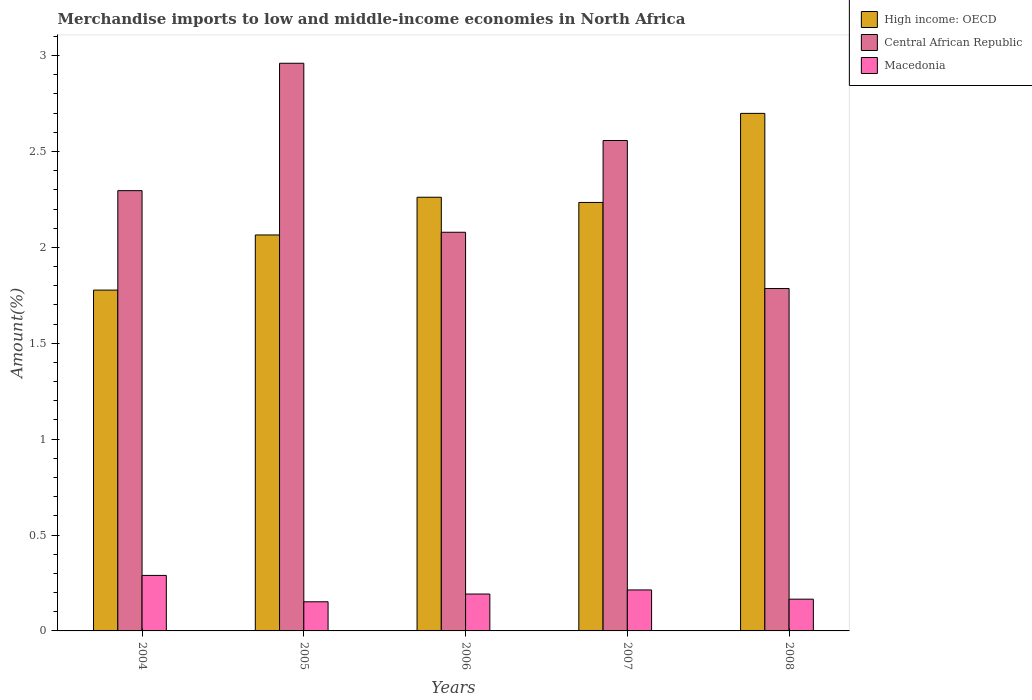How many bars are there on the 3rd tick from the right?
Keep it short and to the point. 3. What is the label of the 3rd group of bars from the left?
Provide a succinct answer. 2006. In how many cases, is the number of bars for a given year not equal to the number of legend labels?
Provide a short and direct response. 0. What is the percentage of amount earned from merchandise imports in Central African Republic in 2004?
Provide a short and direct response. 2.3. Across all years, what is the maximum percentage of amount earned from merchandise imports in High income: OECD?
Provide a succinct answer. 2.7. Across all years, what is the minimum percentage of amount earned from merchandise imports in Central African Republic?
Keep it short and to the point. 1.79. What is the total percentage of amount earned from merchandise imports in Macedonia in the graph?
Offer a terse response. 1.01. What is the difference between the percentage of amount earned from merchandise imports in Central African Republic in 2006 and that in 2007?
Offer a very short reply. -0.48. What is the difference between the percentage of amount earned from merchandise imports in Central African Republic in 2007 and the percentage of amount earned from merchandise imports in High income: OECD in 2004?
Ensure brevity in your answer.  0.78. What is the average percentage of amount earned from merchandise imports in Macedonia per year?
Your answer should be compact. 0.2. In the year 2005, what is the difference between the percentage of amount earned from merchandise imports in Macedonia and percentage of amount earned from merchandise imports in Central African Republic?
Offer a very short reply. -2.81. What is the ratio of the percentage of amount earned from merchandise imports in High income: OECD in 2007 to that in 2008?
Your response must be concise. 0.83. Is the percentage of amount earned from merchandise imports in High income: OECD in 2004 less than that in 2006?
Offer a terse response. Yes. Is the difference between the percentage of amount earned from merchandise imports in Macedonia in 2005 and 2007 greater than the difference between the percentage of amount earned from merchandise imports in Central African Republic in 2005 and 2007?
Your answer should be compact. No. What is the difference between the highest and the second highest percentage of amount earned from merchandise imports in Central African Republic?
Make the answer very short. 0.4. What is the difference between the highest and the lowest percentage of amount earned from merchandise imports in High income: OECD?
Give a very brief answer. 0.92. Is the sum of the percentage of amount earned from merchandise imports in Macedonia in 2005 and 2008 greater than the maximum percentage of amount earned from merchandise imports in High income: OECD across all years?
Ensure brevity in your answer.  No. What does the 2nd bar from the left in 2008 represents?
Make the answer very short. Central African Republic. What does the 3rd bar from the right in 2008 represents?
Your answer should be very brief. High income: OECD. How many bars are there?
Your answer should be very brief. 15. How many years are there in the graph?
Give a very brief answer. 5. Does the graph contain any zero values?
Your response must be concise. No. Does the graph contain grids?
Provide a succinct answer. No. Where does the legend appear in the graph?
Provide a succinct answer. Top right. How are the legend labels stacked?
Offer a very short reply. Vertical. What is the title of the graph?
Provide a short and direct response. Merchandise imports to low and middle-income economies in North Africa. Does "Kazakhstan" appear as one of the legend labels in the graph?
Offer a terse response. No. What is the label or title of the Y-axis?
Provide a succinct answer. Amount(%). What is the Amount(%) in High income: OECD in 2004?
Offer a very short reply. 1.78. What is the Amount(%) of Central African Republic in 2004?
Give a very brief answer. 2.3. What is the Amount(%) of Macedonia in 2004?
Your answer should be compact. 0.29. What is the Amount(%) in High income: OECD in 2005?
Keep it short and to the point. 2.06. What is the Amount(%) in Central African Republic in 2005?
Your answer should be compact. 2.96. What is the Amount(%) in Macedonia in 2005?
Your response must be concise. 0.15. What is the Amount(%) in High income: OECD in 2006?
Your answer should be very brief. 2.26. What is the Amount(%) of Central African Republic in 2006?
Your answer should be very brief. 2.08. What is the Amount(%) in Macedonia in 2006?
Your response must be concise. 0.19. What is the Amount(%) of High income: OECD in 2007?
Offer a terse response. 2.23. What is the Amount(%) in Central African Republic in 2007?
Offer a very short reply. 2.56. What is the Amount(%) in Macedonia in 2007?
Your answer should be very brief. 0.21. What is the Amount(%) of High income: OECD in 2008?
Keep it short and to the point. 2.7. What is the Amount(%) of Central African Republic in 2008?
Offer a very short reply. 1.79. What is the Amount(%) in Macedonia in 2008?
Ensure brevity in your answer.  0.17. Across all years, what is the maximum Amount(%) of High income: OECD?
Offer a terse response. 2.7. Across all years, what is the maximum Amount(%) of Central African Republic?
Provide a succinct answer. 2.96. Across all years, what is the maximum Amount(%) in Macedonia?
Offer a very short reply. 0.29. Across all years, what is the minimum Amount(%) of High income: OECD?
Ensure brevity in your answer.  1.78. Across all years, what is the minimum Amount(%) in Central African Republic?
Offer a very short reply. 1.79. Across all years, what is the minimum Amount(%) of Macedonia?
Your response must be concise. 0.15. What is the total Amount(%) of High income: OECD in the graph?
Keep it short and to the point. 11.04. What is the total Amount(%) in Central African Republic in the graph?
Your response must be concise. 11.68. What is the total Amount(%) of Macedonia in the graph?
Provide a short and direct response. 1.01. What is the difference between the Amount(%) of High income: OECD in 2004 and that in 2005?
Ensure brevity in your answer.  -0.29. What is the difference between the Amount(%) in Central African Republic in 2004 and that in 2005?
Offer a terse response. -0.66. What is the difference between the Amount(%) of Macedonia in 2004 and that in 2005?
Your response must be concise. 0.14. What is the difference between the Amount(%) of High income: OECD in 2004 and that in 2006?
Give a very brief answer. -0.48. What is the difference between the Amount(%) in Central African Republic in 2004 and that in 2006?
Make the answer very short. 0.22. What is the difference between the Amount(%) of Macedonia in 2004 and that in 2006?
Keep it short and to the point. 0.1. What is the difference between the Amount(%) in High income: OECD in 2004 and that in 2007?
Offer a terse response. -0.46. What is the difference between the Amount(%) in Central African Republic in 2004 and that in 2007?
Your answer should be very brief. -0.26. What is the difference between the Amount(%) of Macedonia in 2004 and that in 2007?
Your response must be concise. 0.08. What is the difference between the Amount(%) in High income: OECD in 2004 and that in 2008?
Offer a very short reply. -0.92. What is the difference between the Amount(%) in Central African Republic in 2004 and that in 2008?
Offer a very short reply. 0.51. What is the difference between the Amount(%) in Macedonia in 2004 and that in 2008?
Your response must be concise. 0.12. What is the difference between the Amount(%) in High income: OECD in 2005 and that in 2006?
Offer a terse response. -0.2. What is the difference between the Amount(%) of Central African Republic in 2005 and that in 2006?
Ensure brevity in your answer.  0.88. What is the difference between the Amount(%) of Macedonia in 2005 and that in 2006?
Make the answer very short. -0.04. What is the difference between the Amount(%) of High income: OECD in 2005 and that in 2007?
Keep it short and to the point. -0.17. What is the difference between the Amount(%) in Central African Republic in 2005 and that in 2007?
Your answer should be very brief. 0.4. What is the difference between the Amount(%) in Macedonia in 2005 and that in 2007?
Keep it short and to the point. -0.06. What is the difference between the Amount(%) of High income: OECD in 2005 and that in 2008?
Provide a succinct answer. -0.63. What is the difference between the Amount(%) of Central African Republic in 2005 and that in 2008?
Provide a short and direct response. 1.17. What is the difference between the Amount(%) of Macedonia in 2005 and that in 2008?
Your answer should be compact. -0.01. What is the difference between the Amount(%) of High income: OECD in 2006 and that in 2007?
Make the answer very short. 0.03. What is the difference between the Amount(%) in Central African Republic in 2006 and that in 2007?
Provide a succinct answer. -0.48. What is the difference between the Amount(%) of Macedonia in 2006 and that in 2007?
Give a very brief answer. -0.02. What is the difference between the Amount(%) of High income: OECD in 2006 and that in 2008?
Keep it short and to the point. -0.44. What is the difference between the Amount(%) in Central African Republic in 2006 and that in 2008?
Your answer should be compact. 0.29. What is the difference between the Amount(%) in Macedonia in 2006 and that in 2008?
Keep it short and to the point. 0.03. What is the difference between the Amount(%) of High income: OECD in 2007 and that in 2008?
Give a very brief answer. -0.46. What is the difference between the Amount(%) in Central African Republic in 2007 and that in 2008?
Your response must be concise. 0.77. What is the difference between the Amount(%) of Macedonia in 2007 and that in 2008?
Your answer should be very brief. 0.05. What is the difference between the Amount(%) in High income: OECD in 2004 and the Amount(%) in Central African Republic in 2005?
Offer a terse response. -1.18. What is the difference between the Amount(%) in High income: OECD in 2004 and the Amount(%) in Macedonia in 2005?
Ensure brevity in your answer.  1.63. What is the difference between the Amount(%) in Central African Republic in 2004 and the Amount(%) in Macedonia in 2005?
Give a very brief answer. 2.14. What is the difference between the Amount(%) in High income: OECD in 2004 and the Amount(%) in Central African Republic in 2006?
Give a very brief answer. -0.3. What is the difference between the Amount(%) in High income: OECD in 2004 and the Amount(%) in Macedonia in 2006?
Offer a very short reply. 1.58. What is the difference between the Amount(%) in Central African Republic in 2004 and the Amount(%) in Macedonia in 2006?
Offer a very short reply. 2.1. What is the difference between the Amount(%) of High income: OECD in 2004 and the Amount(%) of Central African Republic in 2007?
Ensure brevity in your answer.  -0.78. What is the difference between the Amount(%) of High income: OECD in 2004 and the Amount(%) of Macedonia in 2007?
Your answer should be very brief. 1.56. What is the difference between the Amount(%) of Central African Republic in 2004 and the Amount(%) of Macedonia in 2007?
Your answer should be compact. 2.08. What is the difference between the Amount(%) of High income: OECD in 2004 and the Amount(%) of Central African Republic in 2008?
Make the answer very short. -0.01. What is the difference between the Amount(%) of High income: OECD in 2004 and the Amount(%) of Macedonia in 2008?
Make the answer very short. 1.61. What is the difference between the Amount(%) of Central African Republic in 2004 and the Amount(%) of Macedonia in 2008?
Offer a very short reply. 2.13. What is the difference between the Amount(%) in High income: OECD in 2005 and the Amount(%) in Central African Republic in 2006?
Your answer should be very brief. -0.01. What is the difference between the Amount(%) of High income: OECD in 2005 and the Amount(%) of Macedonia in 2006?
Make the answer very short. 1.87. What is the difference between the Amount(%) of Central African Republic in 2005 and the Amount(%) of Macedonia in 2006?
Your answer should be very brief. 2.77. What is the difference between the Amount(%) in High income: OECD in 2005 and the Amount(%) in Central African Republic in 2007?
Provide a succinct answer. -0.49. What is the difference between the Amount(%) of High income: OECD in 2005 and the Amount(%) of Macedonia in 2007?
Offer a terse response. 1.85. What is the difference between the Amount(%) in Central African Republic in 2005 and the Amount(%) in Macedonia in 2007?
Offer a very short reply. 2.75. What is the difference between the Amount(%) of High income: OECD in 2005 and the Amount(%) of Central African Republic in 2008?
Provide a short and direct response. 0.28. What is the difference between the Amount(%) of High income: OECD in 2005 and the Amount(%) of Macedonia in 2008?
Provide a short and direct response. 1.9. What is the difference between the Amount(%) of Central African Republic in 2005 and the Amount(%) of Macedonia in 2008?
Offer a very short reply. 2.79. What is the difference between the Amount(%) in High income: OECD in 2006 and the Amount(%) in Central African Republic in 2007?
Provide a succinct answer. -0.3. What is the difference between the Amount(%) in High income: OECD in 2006 and the Amount(%) in Macedonia in 2007?
Give a very brief answer. 2.05. What is the difference between the Amount(%) in Central African Republic in 2006 and the Amount(%) in Macedonia in 2007?
Give a very brief answer. 1.87. What is the difference between the Amount(%) of High income: OECD in 2006 and the Amount(%) of Central African Republic in 2008?
Keep it short and to the point. 0.48. What is the difference between the Amount(%) of High income: OECD in 2006 and the Amount(%) of Macedonia in 2008?
Provide a succinct answer. 2.1. What is the difference between the Amount(%) in Central African Republic in 2006 and the Amount(%) in Macedonia in 2008?
Offer a very short reply. 1.91. What is the difference between the Amount(%) in High income: OECD in 2007 and the Amount(%) in Central African Republic in 2008?
Keep it short and to the point. 0.45. What is the difference between the Amount(%) in High income: OECD in 2007 and the Amount(%) in Macedonia in 2008?
Provide a short and direct response. 2.07. What is the difference between the Amount(%) of Central African Republic in 2007 and the Amount(%) of Macedonia in 2008?
Give a very brief answer. 2.39. What is the average Amount(%) of High income: OECD per year?
Provide a succinct answer. 2.21. What is the average Amount(%) in Central African Republic per year?
Make the answer very short. 2.34. What is the average Amount(%) in Macedonia per year?
Keep it short and to the point. 0.2. In the year 2004, what is the difference between the Amount(%) of High income: OECD and Amount(%) of Central African Republic?
Your response must be concise. -0.52. In the year 2004, what is the difference between the Amount(%) in High income: OECD and Amount(%) in Macedonia?
Your answer should be compact. 1.49. In the year 2004, what is the difference between the Amount(%) of Central African Republic and Amount(%) of Macedonia?
Your response must be concise. 2.01. In the year 2005, what is the difference between the Amount(%) of High income: OECD and Amount(%) of Central African Republic?
Provide a short and direct response. -0.9. In the year 2005, what is the difference between the Amount(%) in High income: OECD and Amount(%) in Macedonia?
Your answer should be very brief. 1.91. In the year 2005, what is the difference between the Amount(%) of Central African Republic and Amount(%) of Macedonia?
Your answer should be compact. 2.81. In the year 2006, what is the difference between the Amount(%) in High income: OECD and Amount(%) in Central African Republic?
Make the answer very short. 0.18. In the year 2006, what is the difference between the Amount(%) in High income: OECD and Amount(%) in Macedonia?
Provide a succinct answer. 2.07. In the year 2006, what is the difference between the Amount(%) in Central African Republic and Amount(%) in Macedonia?
Your answer should be compact. 1.89. In the year 2007, what is the difference between the Amount(%) of High income: OECD and Amount(%) of Central African Republic?
Your answer should be very brief. -0.32. In the year 2007, what is the difference between the Amount(%) of High income: OECD and Amount(%) of Macedonia?
Give a very brief answer. 2.02. In the year 2007, what is the difference between the Amount(%) in Central African Republic and Amount(%) in Macedonia?
Keep it short and to the point. 2.34. In the year 2008, what is the difference between the Amount(%) of High income: OECD and Amount(%) of Central African Republic?
Keep it short and to the point. 0.91. In the year 2008, what is the difference between the Amount(%) in High income: OECD and Amount(%) in Macedonia?
Your answer should be very brief. 2.53. In the year 2008, what is the difference between the Amount(%) in Central African Republic and Amount(%) in Macedonia?
Offer a very short reply. 1.62. What is the ratio of the Amount(%) of High income: OECD in 2004 to that in 2005?
Your response must be concise. 0.86. What is the ratio of the Amount(%) in Central African Republic in 2004 to that in 2005?
Provide a short and direct response. 0.78. What is the ratio of the Amount(%) of Macedonia in 2004 to that in 2005?
Make the answer very short. 1.91. What is the ratio of the Amount(%) in High income: OECD in 2004 to that in 2006?
Provide a short and direct response. 0.79. What is the ratio of the Amount(%) of Central African Republic in 2004 to that in 2006?
Provide a short and direct response. 1.1. What is the ratio of the Amount(%) of Macedonia in 2004 to that in 2006?
Ensure brevity in your answer.  1.5. What is the ratio of the Amount(%) in High income: OECD in 2004 to that in 2007?
Make the answer very short. 0.8. What is the ratio of the Amount(%) of Central African Republic in 2004 to that in 2007?
Your answer should be very brief. 0.9. What is the ratio of the Amount(%) in Macedonia in 2004 to that in 2007?
Your answer should be very brief. 1.35. What is the ratio of the Amount(%) in High income: OECD in 2004 to that in 2008?
Make the answer very short. 0.66. What is the ratio of the Amount(%) in Central African Republic in 2004 to that in 2008?
Ensure brevity in your answer.  1.29. What is the ratio of the Amount(%) in Macedonia in 2004 to that in 2008?
Offer a terse response. 1.75. What is the ratio of the Amount(%) in High income: OECD in 2005 to that in 2006?
Keep it short and to the point. 0.91. What is the ratio of the Amount(%) in Central African Republic in 2005 to that in 2006?
Provide a succinct answer. 1.42. What is the ratio of the Amount(%) of Macedonia in 2005 to that in 2006?
Keep it short and to the point. 0.79. What is the ratio of the Amount(%) of High income: OECD in 2005 to that in 2007?
Your answer should be very brief. 0.92. What is the ratio of the Amount(%) of Central African Republic in 2005 to that in 2007?
Ensure brevity in your answer.  1.16. What is the ratio of the Amount(%) in Macedonia in 2005 to that in 2007?
Ensure brevity in your answer.  0.71. What is the ratio of the Amount(%) in High income: OECD in 2005 to that in 2008?
Provide a short and direct response. 0.77. What is the ratio of the Amount(%) of Central African Republic in 2005 to that in 2008?
Make the answer very short. 1.66. What is the ratio of the Amount(%) of Macedonia in 2005 to that in 2008?
Provide a short and direct response. 0.92. What is the ratio of the Amount(%) in High income: OECD in 2006 to that in 2007?
Keep it short and to the point. 1.01. What is the ratio of the Amount(%) of Central African Republic in 2006 to that in 2007?
Ensure brevity in your answer.  0.81. What is the ratio of the Amount(%) of Macedonia in 2006 to that in 2007?
Your response must be concise. 0.9. What is the ratio of the Amount(%) in High income: OECD in 2006 to that in 2008?
Ensure brevity in your answer.  0.84. What is the ratio of the Amount(%) in Central African Republic in 2006 to that in 2008?
Offer a terse response. 1.16. What is the ratio of the Amount(%) of Macedonia in 2006 to that in 2008?
Provide a short and direct response. 1.16. What is the ratio of the Amount(%) of High income: OECD in 2007 to that in 2008?
Offer a very short reply. 0.83. What is the ratio of the Amount(%) in Central African Republic in 2007 to that in 2008?
Ensure brevity in your answer.  1.43. What is the ratio of the Amount(%) of Macedonia in 2007 to that in 2008?
Offer a terse response. 1.29. What is the difference between the highest and the second highest Amount(%) in High income: OECD?
Offer a terse response. 0.44. What is the difference between the highest and the second highest Amount(%) of Central African Republic?
Your answer should be compact. 0.4. What is the difference between the highest and the second highest Amount(%) in Macedonia?
Ensure brevity in your answer.  0.08. What is the difference between the highest and the lowest Amount(%) in High income: OECD?
Offer a terse response. 0.92. What is the difference between the highest and the lowest Amount(%) in Central African Republic?
Make the answer very short. 1.17. What is the difference between the highest and the lowest Amount(%) in Macedonia?
Ensure brevity in your answer.  0.14. 